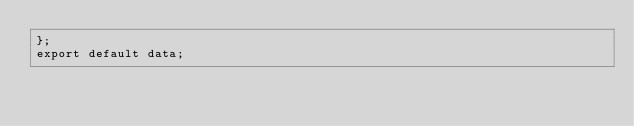<code> <loc_0><loc_0><loc_500><loc_500><_JavaScript_>};
export default data;
</code> 